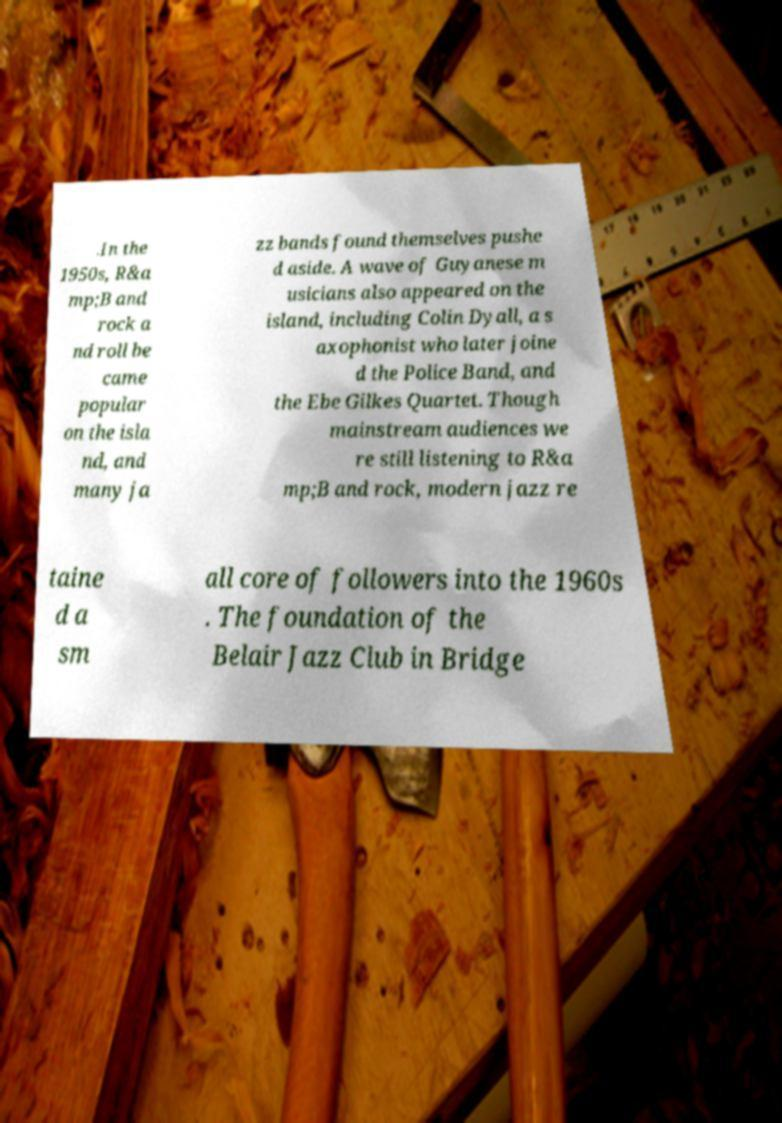I need the written content from this picture converted into text. Can you do that? .In the 1950s, R&a mp;B and rock a nd roll be came popular on the isla nd, and many ja zz bands found themselves pushe d aside. A wave of Guyanese m usicians also appeared on the island, including Colin Dyall, a s axophonist who later joine d the Police Band, and the Ebe Gilkes Quartet. Though mainstream audiences we re still listening to R&a mp;B and rock, modern jazz re taine d a sm all core of followers into the 1960s . The foundation of the Belair Jazz Club in Bridge 